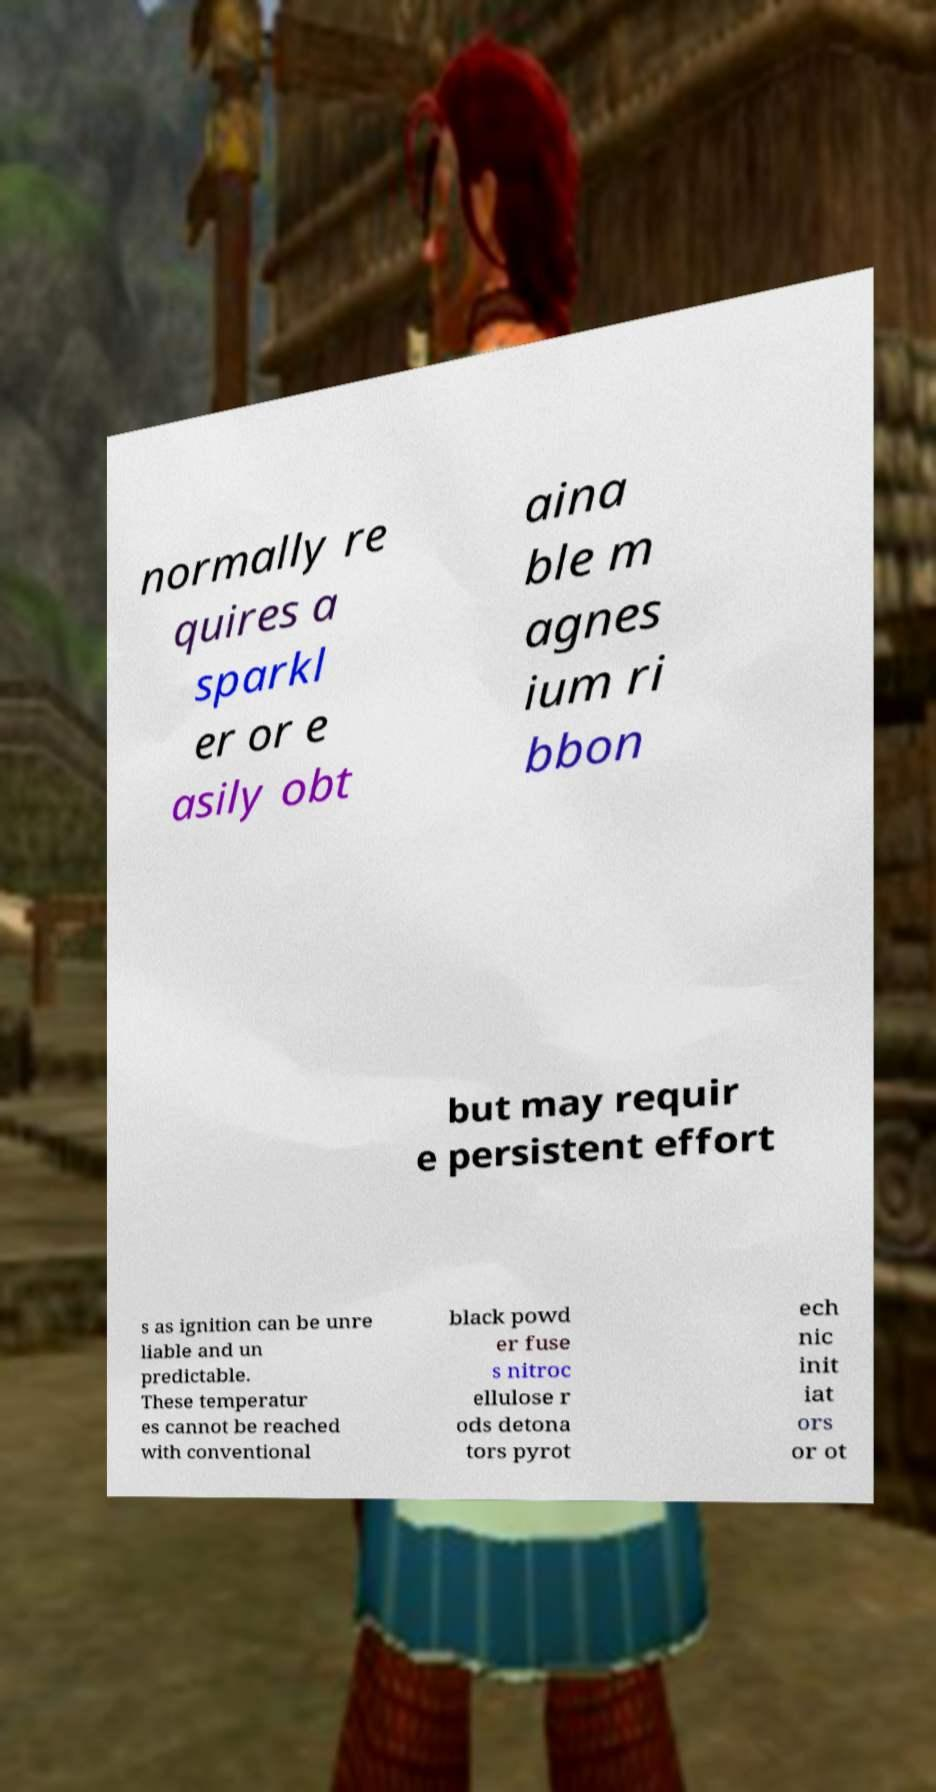There's text embedded in this image that I need extracted. Can you transcribe it verbatim? normally re quires a sparkl er or e asily obt aina ble m agnes ium ri bbon but may requir e persistent effort s as ignition can be unre liable and un predictable. These temperatur es cannot be reached with conventional black powd er fuse s nitroc ellulose r ods detona tors pyrot ech nic init iat ors or ot 